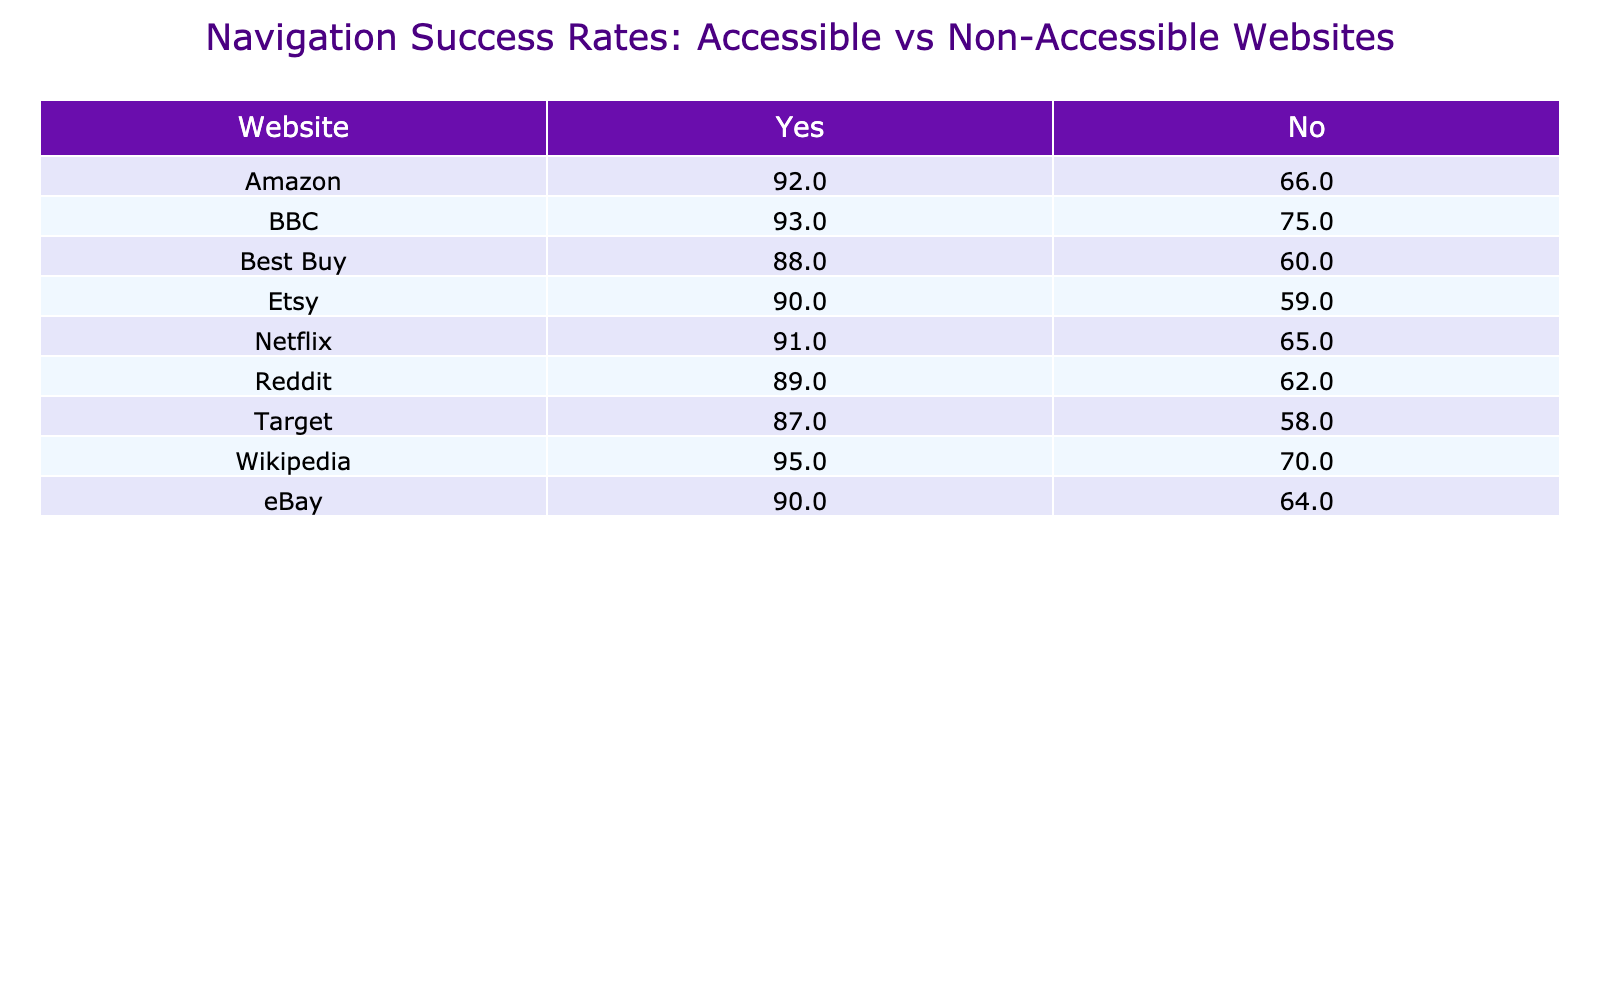What is the navigation success rate for Amazon when accessibility features are enabled? Referring to the table, the navigation success rate for Amazon with accessibility features is listed as 92%.
Answer: 92% What is the navigation success rate for eBay without accessibility features? By checking the eBay row in the table, the success rate without accessibility features is noted as 64%.
Answer: 64% Which website has the highest navigation success rate with accessibility features? The table shows BBC with a navigation success rate of 93% when accessibility features are enabled, which is the highest among all listed websites.
Answer: BBC What is the average navigation success rate for websites without accessibility features? Adding the navigation success rates for each website without accessibility features (66 + 64 + 58 + 75 + 70 + 60 + 65 + 62 + 59 =  709) and dividing by the total number of websites (9), gives an average of 709/9 = 78.78%.
Answer: 78.78% Is the navigation success rate for Netflix higher with accessibility features compared to without? Comparing the two values from the table, Netflix has a success rate of 91% with accessibility features and 65% without, indicating that it is indeed higher.
Answer: Yes What is the difference in navigation success rates between websites with and without accessibility features for Target? Target’s success rate with accessibility features is 87%, while without it is 58%. The difference is calculated as 87 - 58 = 29%.
Answer: 29% Which website has the lowest navigation success rate when accessibility features are not present? By looking at the column for 'No' in the table, Etsy has the lowest success rate at 59% without accessibility features.
Answer: Etsy If we combine navigation success rates for websites with accessibility features, what is the total percentage? The total is calculated by summing each value from the 'Yes' column: 92 + 90 + 87 + 93 + 95 + 88 + 91 + 89 + 90 = 915%.
Answer: 915% Is it true that all websites have a higher navigation success rate when accessibility features are enabled compared to when they are not? By evaluating the table, all websites listed show higher success rates for the 'Yes' column compared to their 'No' counterpart, confirming this statement as correct.
Answer: Yes 